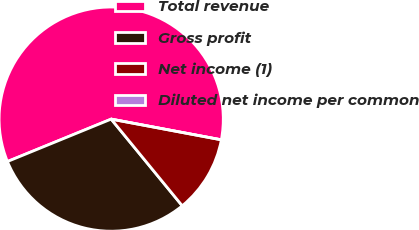<chart> <loc_0><loc_0><loc_500><loc_500><pie_chart><fcel>Total revenue<fcel>Gross profit<fcel>Net income (1)<fcel>Diluted net income per common<nl><fcel>59.13%<fcel>29.75%<fcel>11.11%<fcel>0.0%<nl></chart> 